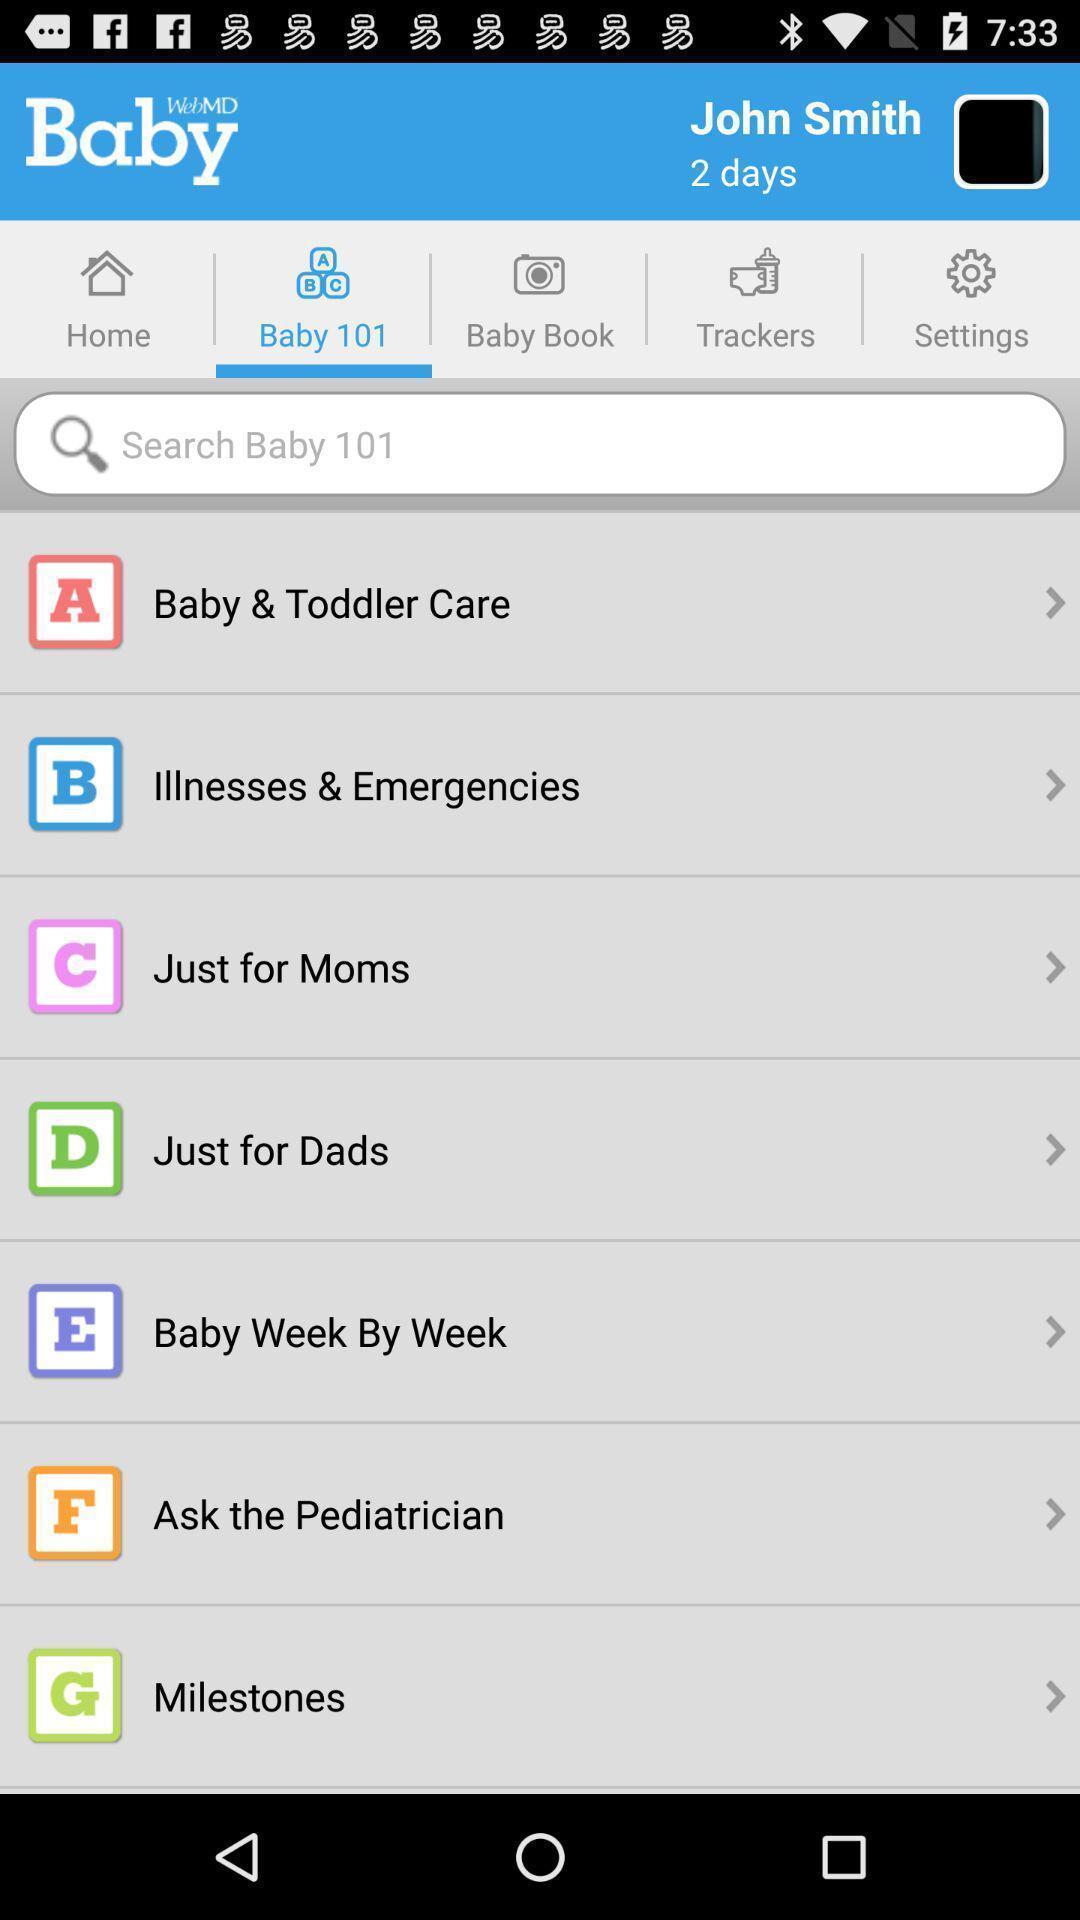Describe the visual elements of this screenshot. Page showing the various categories in baby tab. 